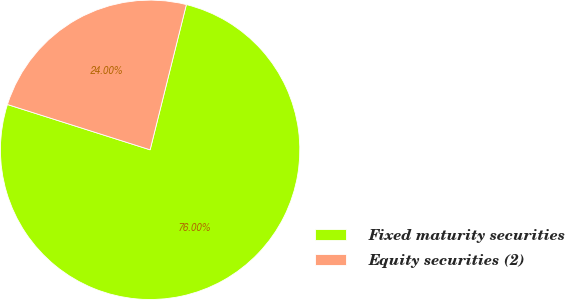Convert chart. <chart><loc_0><loc_0><loc_500><loc_500><pie_chart><fcel>Fixed maturity securities<fcel>Equity securities (2)<nl><fcel>76.0%<fcel>24.0%<nl></chart> 